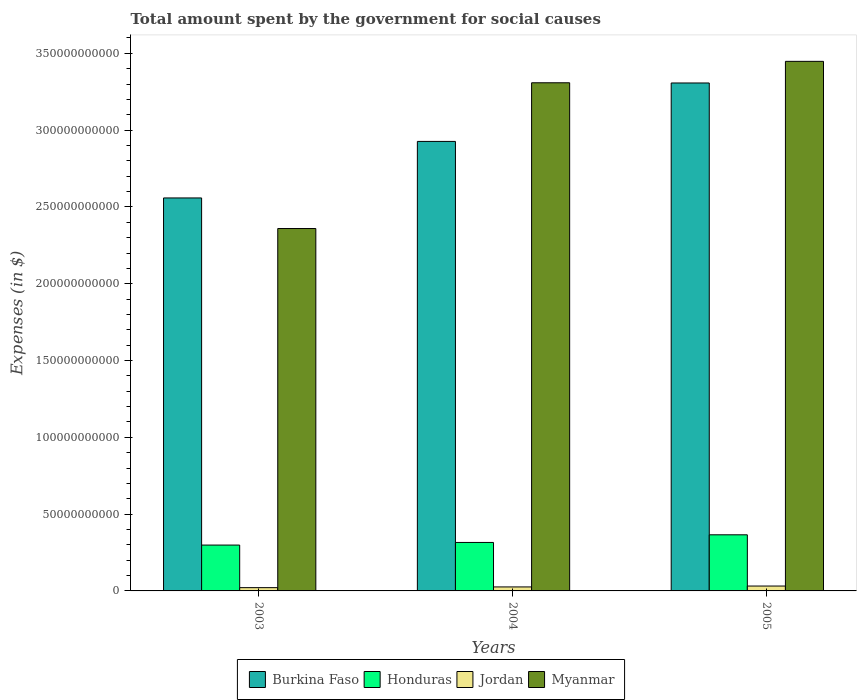How many different coloured bars are there?
Keep it short and to the point. 4. What is the label of the 3rd group of bars from the left?
Your answer should be very brief. 2005. In how many cases, is the number of bars for a given year not equal to the number of legend labels?
Provide a short and direct response. 0. What is the amount spent for social causes by the government in Myanmar in 2004?
Make the answer very short. 3.31e+11. Across all years, what is the maximum amount spent for social causes by the government in Myanmar?
Offer a terse response. 3.45e+11. Across all years, what is the minimum amount spent for social causes by the government in Honduras?
Your answer should be very brief. 2.99e+1. In which year was the amount spent for social causes by the government in Burkina Faso minimum?
Give a very brief answer. 2003. What is the total amount spent for social causes by the government in Myanmar in the graph?
Provide a short and direct response. 9.12e+11. What is the difference between the amount spent for social causes by the government in Jordan in 2004 and that in 2005?
Give a very brief answer. -5.82e+08. What is the difference between the amount spent for social causes by the government in Jordan in 2003 and the amount spent for social causes by the government in Burkina Faso in 2004?
Provide a short and direct response. -2.91e+11. What is the average amount spent for social causes by the government in Burkina Faso per year?
Your response must be concise. 2.93e+11. In the year 2003, what is the difference between the amount spent for social causes by the government in Burkina Faso and amount spent for social causes by the government in Jordan?
Your response must be concise. 2.54e+11. What is the ratio of the amount spent for social causes by the government in Jordan in 2003 to that in 2004?
Provide a succinct answer. 0.82. Is the difference between the amount spent for social causes by the government in Burkina Faso in 2003 and 2005 greater than the difference between the amount spent for social causes by the government in Jordan in 2003 and 2005?
Give a very brief answer. No. What is the difference between the highest and the second highest amount spent for social causes by the government in Jordan?
Offer a very short reply. 5.82e+08. What is the difference between the highest and the lowest amount spent for social causes by the government in Myanmar?
Your answer should be compact. 1.09e+11. In how many years, is the amount spent for social causes by the government in Jordan greater than the average amount spent for social causes by the government in Jordan taken over all years?
Your answer should be compact. 1. Is the sum of the amount spent for social causes by the government in Honduras in 2004 and 2005 greater than the maximum amount spent for social causes by the government in Burkina Faso across all years?
Provide a short and direct response. No. Is it the case that in every year, the sum of the amount spent for social causes by the government in Burkina Faso and amount spent for social causes by the government in Honduras is greater than the sum of amount spent for social causes by the government in Jordan and amount spent for social causes by the government in Myanmar?
Offer a terse response. Yes. What does the 4th bar from the left in 2003 represents?
Give a very brief answer. Myanmar. What does the 4th bar from the right in 2003 represents?
Provide a succinct answer. Burkina Faso. Is it the case that in every year, the sum of the amount spent for social causes by the government in Honduras and amount spent for social causes by the government in Burkina Faso is greater than the amount spent for social causes by the government in Myanmar?
Your answer should be compact. No. How many bars are there?
Offer a terse response. 12. How many years are there in the graph?
Offer a very short reply. 3. Does the graph contain grids?
Keep it short and to the point. No. How are the legend labels stacked?
Make the answer very short. Horizontal. What is the title of the graph?
Your answer should be very brief. Total amount spent by the government for social causes. Does "Kiribati" appear as one of the legend labels in the graph?
Your answer should be very brief. No. What is the label or title of the Y-axis?
Provide a succinct answer. Expenses (in $). What is the Expenses (in $) in Burkina Faso in 2003?
Keep it short and to the point. 2.56e+11. What is the Expenses (in $) of Honduras in 2003?
Make the answer very short. 2.99e+1. What is the Expenses (in $) in Jordan in 2003?
Ensure brevity in your answer.  2.13e+09. What is the Expenses (in $) in Myanmar in 2003?
Your answer should be compact. 2.36e+11. What is the Expenses (in $) in Burkina Faso in 2004?
Keep it short and to the point. 2.93e+11. What is the Expenses (in $) of Honduras in 2004?
Offer a terse response. 3.16e+1. What is the Expenses (in $) in Jordan in 2004?
Offer a terse response. 2.60e+09. What is the Expenses (in $) of Myanmar in 2004?
Your answer should be compact. 3.31e+11. What is the Expenses (in $) of Burkina Faso in 2005?
Offer a terse response. 3.31e+11. What is the Expenses (in $) of Honduras in 2005?
Your answer should be compact. 3.65e+1. What is the Expenses (in $) in Jordan in 2005?
Offer a terse response. 3.18e+09. What is the Expenses (in $) in Myanmar in 2005?
Ensure brevity in your answer.  3.45e+11. Across all years, what is the maximum Expenses (in $) in Burkina Faso?
Your response must be concise. 3.31e+11. Across all years, what is the maximum Expenses (in $) of Honduras?
Your response must be concise. 3.65e+1. Across all years, what is the maximum Expenses (in $) in Jordan?
Offer a terse response. 3.18e+09. Across all years, what is the maximum Expenses (in $) in Myanmar?
Provide a succinct answer. 3.45e+11. Across all years, what is the minimum Expenses (in $) of Burkina Faso?
Your answer should be compact. 2.56e+11. Across all years, what is the minimum Expenses (in $) in Honduras?
Make the answer very short. 2.99e+1. Across all years, what is the minimum Expenses (in $) of Jordan?
Your answer should be compact. 2.13e+09. Across all years, what is the minimum Expenses (in $) of Myanmar?
Your answer should be compact. 2.36e+11. What is the total Expenses (in $) in Burkina Faso in the graph?
Provide a short and direct response. 8.79e+11. What is the total Expenses (in $) in Honduras in the graph?
Provide a short and direct response. 9.79e+1. What is the total Expenses (in $) of Jordan in the graph?
Offer a very short reply. 7.91e+09. What is the total Expenses (in $) of Myanmar in the graph?
Offer a terse response. 9.12e+11. What is the difference between the Expenses (in $) in Burkina Faso in 2003 and that in 2004?
Make the answer very short. -3.68e+1. What is the difference between the Expenses (in $) in Honduras in 2003 and that in 2004?
Your answer should be very brief. -1.71e+09. What is the difference between the Expenses (in $) in Jordan in 2003 and that in 2004?
Ensure brevity in your answer.  -4.70e+08. What is the difference between the Expenses (in $) of Myanmar in 2003 and that in 2004?
Ensure brevity in your answer.  -9.49e+1. What is the difference between the Expenses (in $) in Burkina Faso in 2003 and that in 2005?
Make the answer very short. -7.48e+1. What is the difference between the Expenses (in $) in Honduras in 2003 and that in 2005?
Your answer should be very brief. -6.68e+09. What is the difference between the Expenses (in $) in Jordan in 2003 and that in 2005?
Your answer should be compact. -1.05e+09. What is the difference between the Expenses (in $) in Myanmar in 2003 and that in 2005?
Offer a terse response. -1.09e+11. What is the difference between the Expenses (in $) of Burkina Faso in 2004 and that in 2005?
Provide a short and direct response. -3.80e+1. What is the difference between the Expenses (in $) of Honduras in 2004 and that in 2005?
Your answer should be very brief. -4.97e+09. What is the difference between the Expenses (in $) in Jordan in 2004 and that in 2005?
Offer a terse response. -5.82e+08. What is the difference between the Expenses (in $) of Myanmar in 2004 and that in 2005?
Your answer should be compact. -1.39e+1. What is the difference between the Expenses (in $) of Burkina Faso in 2003 and the Expenses (in $) of Honduras in 2004?
Offer a very short reply. 2.24e+11. What is the difference between the Expenses (in $) of Burkina Faso in 2003 and the Expenses (in $) of Jordan in 2004?
Offer a terse response. 2.53e+11. What is the difference between the Expenses (in $) of Burkina Faso in 2003 and the Expenses (in $) of Myanmar in 2004?
Your answer should be very brief. -7.50e+1. What is the difference between the Expenses (in $) of Honduras in 2003 and the Expenses (in $) of Jordan in 2004?
Your response must be concise. 2.73e+1. What is the difference between the Expenses (in $) in Honduras in 2003 and the Expenses (in $) in Myanmar in 2004?
Offer a very short reply. -3.01e+11. What is the difference between the Expenses (in $) in Jordan in 2003 and the Expenses (in $) in Myanmar in 2004?
Your answer should be very brief. -3.29e+11. What is the difference between the Expenses (in $) in Burkina Faso in 2003 and the Expenses (in $) in Honduras in 2005?
Make the answer very short. 2.19e+11. What is the difference between the Expenses (in $) in Burkina Faso in 2003 and the Expenses (in $) in Jordan in 2005?
Your response must be concise. 2.53e+11. What is the difference between the Expenses (in $) in Burkina Faso in 2003 and the Expenses (in $) in Myanmar in 2005?
Give a very brief answer. -8.89e+1. What is the difference between the Expenses (in $) of Honduras in 2003 and the Expenses (in $) of Jordan in 2005?
Ensure brevity in your answer.  2.67e+1. What is the difference between the Expenses (in $) in Honduras in 2003 and the Expenses (in $) in Myanmar in 2005?
Make the answer very short. -3.15e+11. What is the difference between the Expenses (in $) of Jordan in 2003 and the Expenses (in $) of Myanmar in 2005?
Give a very brief answer. -3.43e+11. What is the difference between the Expenses (in $) of Burkina Faso in 2004 and the Expenses (in $) of Honduras in 2005?
Give a very brief answer. 2.56e+11. What is the difference between the Expenses (in $) in Burkina Faso in 2004 and the Expenses (in $) in Jordan in 2005?
Provide a short and direct response. 2.89e+11. What is the difference between the Expenses (in $) of Burkina Faso in 2004 and the Expenses (in $) of Myanmar in 2005?
Make the answer very short. -5.21e+1. What is the difference between the Expenses (in $) of Honduras in 2004 and the Expenses (in $) of Jordan in 2005?
Keep it short and to the point. 2.84e+1. What is the difference between the Expenses (in $) in Honduras in 2004 and the Expenses (in $) in Myanmar in 2005?
Provide a short and direct response. -3.13e+11. What is the difference between the Expenses (in $) in Jordan in 2004 and the Expenses (in $) in Myanmar in 2005?
Offer a very short reply. -3.42e+11. What is the average Expenses (in $) in Burkina Faso per year?
Your response must be concise. 2.93e+11. What is the average Expenses (in $) of Honduras per year?
Give a very brief answer. 3.26e+1. What is the average Expenses (in $) in Jordan per year?
Make the answer very short. 2.64e+09. What is the average Expenses (in $) in Myanmar per year?
Ensure brevity in your answer.  3.04e+11. In the year 2003, what is the difference between the Expenses (in $) in Burkina Faso and Expenses (in $) in Honduras?
Keep it short and to the point. 2.26e+11. In the year 2003, what is the difference between the Expenses (in $) in Burkina Faso and Expenses (in $) in Jordan?
Give a very brief answer. 2.54e+11. In the year 2003, what is the difference between the Expenses (in $) in Burkina Faso and Expenses (in $) in Myanmar?
Give a very brief answer. 1.99e+1. In the year 2003, what is the difference between the Expenses (in $) of Honduras and Expenses (in $) of Jordan?
Your answer should be very brief. 2.77e+1. In the year 2003, what is the difference between the Expenses (in $) of Honduras and Expenses (in $) of Myanmar?
Provide a succinct answer. -2.06e+11. In the year 2003, what is the difference between the Expenses (in $) of Jordan and Expenses (in $) of Myanmar?
Offer a terse response. -2.34e+11. In the year 2004, what is the difference between the Expenses (in $) of Burkina Faso and Expenses (in $) of Honduras?
Ensure brevity in your answer.  2.61e+11. In the year 2004, what is the difference between the Expenses (in $) in Burkina Faso and Expenses (in $) in Jordan?
Offer a terse response. 2.90e+11. In the year 2004, what is the difference between the Expenses (in $) of Burkina Faso and Expenses (in $) of Myanmar?
Your answer should be compact. -3.82e+1. In the year 2004, what is the difference between the Expenses (in $) in Honduras and Expenses (in $) in Jordan?
Your answer should be compact. 2.90e+1. In the year 2004, what is the difference between the Expenses (in $) in Honduras and Expenses (in $) in Myanmar?
Provide a succinct answer. -2.99e+11. In the year 2004, what is the difference between the Expenses (in $) of Jordan and Expenses (in $) of Myanmar?
Your response must be concise. -3.28e+11. In the year 2005, what is the difference between the Expenses (in $) of Burkina Faso and Expenses (in $) of Honduras?
Your answer should be very brief. 2.94e+11. In the year 2005, what is the difference between the Expenses (in $) of Burkina Faso and Expenses (in $) of Jordan?
Make the answer very short. 3.28e+11. In the year 2005, what is the difference between the Expenses (in $) of Burkina Faso and Expenses (in $) of Myanmar?
Offer a very short reply. -1.41e+1. In the year 2005, what is the difference between the Expenses (in $) in Honduras and Expenses (in $) in Jordan?
Keep it short and to the point. 3.34e+1. In the year 2005, what is the difference between the Expenses (in $) in Honduras and Expenses (in $) in Myanmar?
Give a very brief answer. -3.08e+11. In the year 2005, what is the difference between the Expenses (in $) of Jordan and Expenses (in $) of Myanmar?
Your answer should be compact. -3.42e+11. What is the ratio of the Expenses (in $) in Burkina Faso in 2003 to that in 2004?
Provide a succinct answer. 0.87. What is the ratio of the Expenses (in $) of Honduras in 2003 to that in 2004?
Provide a succinct answer. 0.95. What is the ratio of the Expenses (in $) in Jordan in 2003 to that in 2004?
Your answer should be compact. 0.82. What is the ratio of the Expenses (in $) in Myanmar in 2003 to that in 2004?
Make the answer very short. 0.71. What is the ratio of the Expenses (in $) of Burkina Faso in 2003 to that in 2005?
Offer a terse response. 0.77. What is the ratio of the Expenses (in $) in Honduras in 2003 to that in 2005?
Your response must be concise. 0.82. What is the ratio of the Expenses (in $) in Jordan in 2003 to that in 2005?
Make the answer very short. 0.67. What is the ratio of the Expenses (in $) of Myanmar in 2003 to that in 2005?
Give a very brief answer. 0.68. What is the ratio of the Expenses (in $) of Burkina Faso in 2004 to that in 2005?
Your response must be concise. 0.89. What is the ratio of the Expenses (in $) in Honduras in 2004 to that in 2005?
Ensure brevity in your answer.  0.86. What is the ratio of the Expenses (in $) of Jordan in 2004 to that in 2005?
Your answer should be compact. 0.82. What is the ratio of the Expenses (in $) of Myanmar in 2004 to that in 2005?
Ensure brevity in your answer.  0.96. What is the difference between the highest and the second highest Expenses (in $) of Burkina Faso?
Your response must be concise. 3.80e+1. What is the difference between the highest and the second highest Expenses (in $) of Honduras?
Your answer should be compact. 4.97e+09. What is the difference between the highest and the second highest Expenses (in $) in Jordan?
Provide a succinct answer. 5.82e+08. What is the difference between the highest and the second highest Expenses (in $) in Myanmar?
Make the answer very short. 1.39e+1. What is the difference between the highest and the lowest Expenses (in $) of Burkina Faso?
Ensure brevity in your answer.  7.48e+1. What is the difference between the highest and the lowest Expenses (in $) of Honduras?
Your response must be concise. 6.68e+09. What is the difference between the highest and the lowest Expenses (in $) in Jordan?
Provide a short and direct response. 1.05e+09. What is the difference between the highest and the lowest Expenses (in $) in Myanmar?
Give a very brief answer. 1.09e+11. 